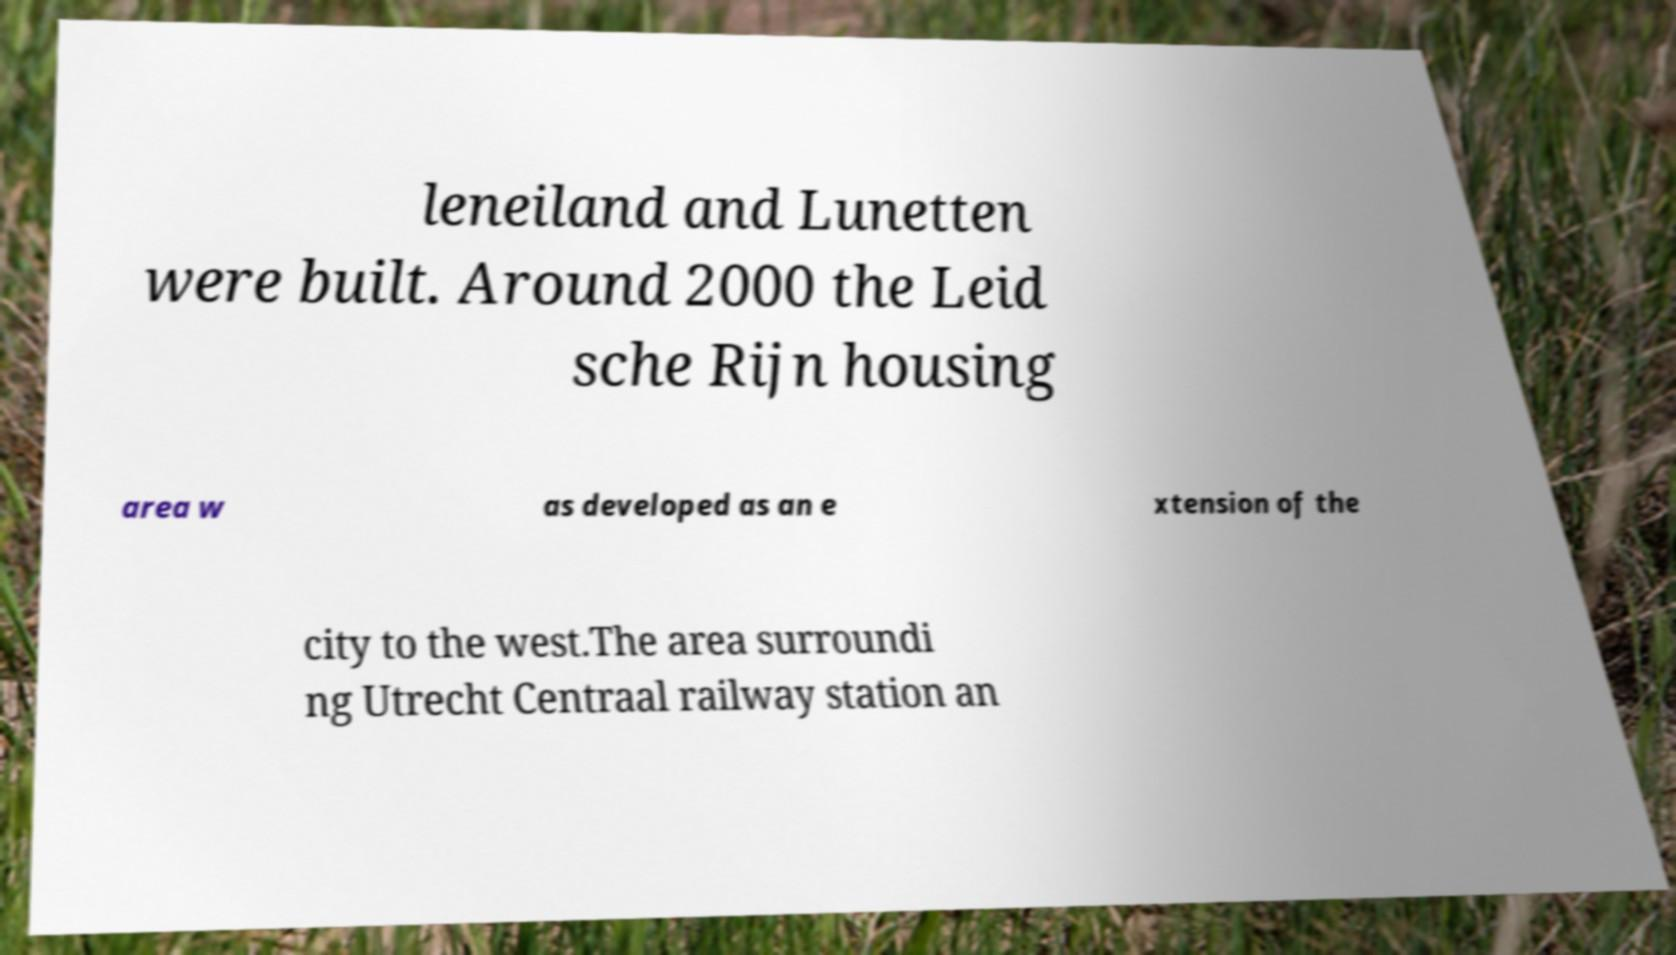For documentation purposes, I need the text within this image transcribed. Could you provide that? leneiland and Lunetten were built. Around 2000 the Leid sche Rijn housing area w as developed as an e xtension of the city to the west.The area surroundi ng Utrecht Centraal railway station an 